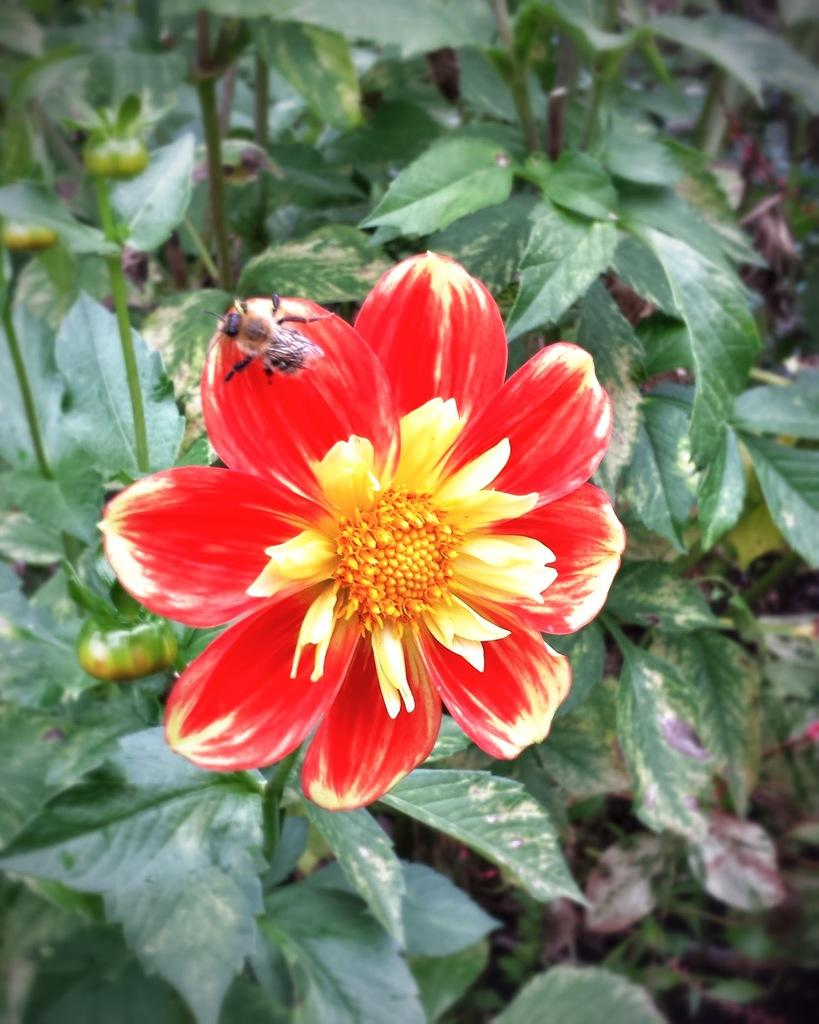What is the main subject of the image? The main subject of the image is a flower. Where is the flower located? The flower is on a plant. What colors can be seen on the flower? The flower has red and yellow colors. Are there any other living organisms present in the image? Yes, there is a bee on the flower. What type of screw is being used to hold the apparatus together in the image? There is no screw or apparatus present in the image; it features a flower with a bee on it. 